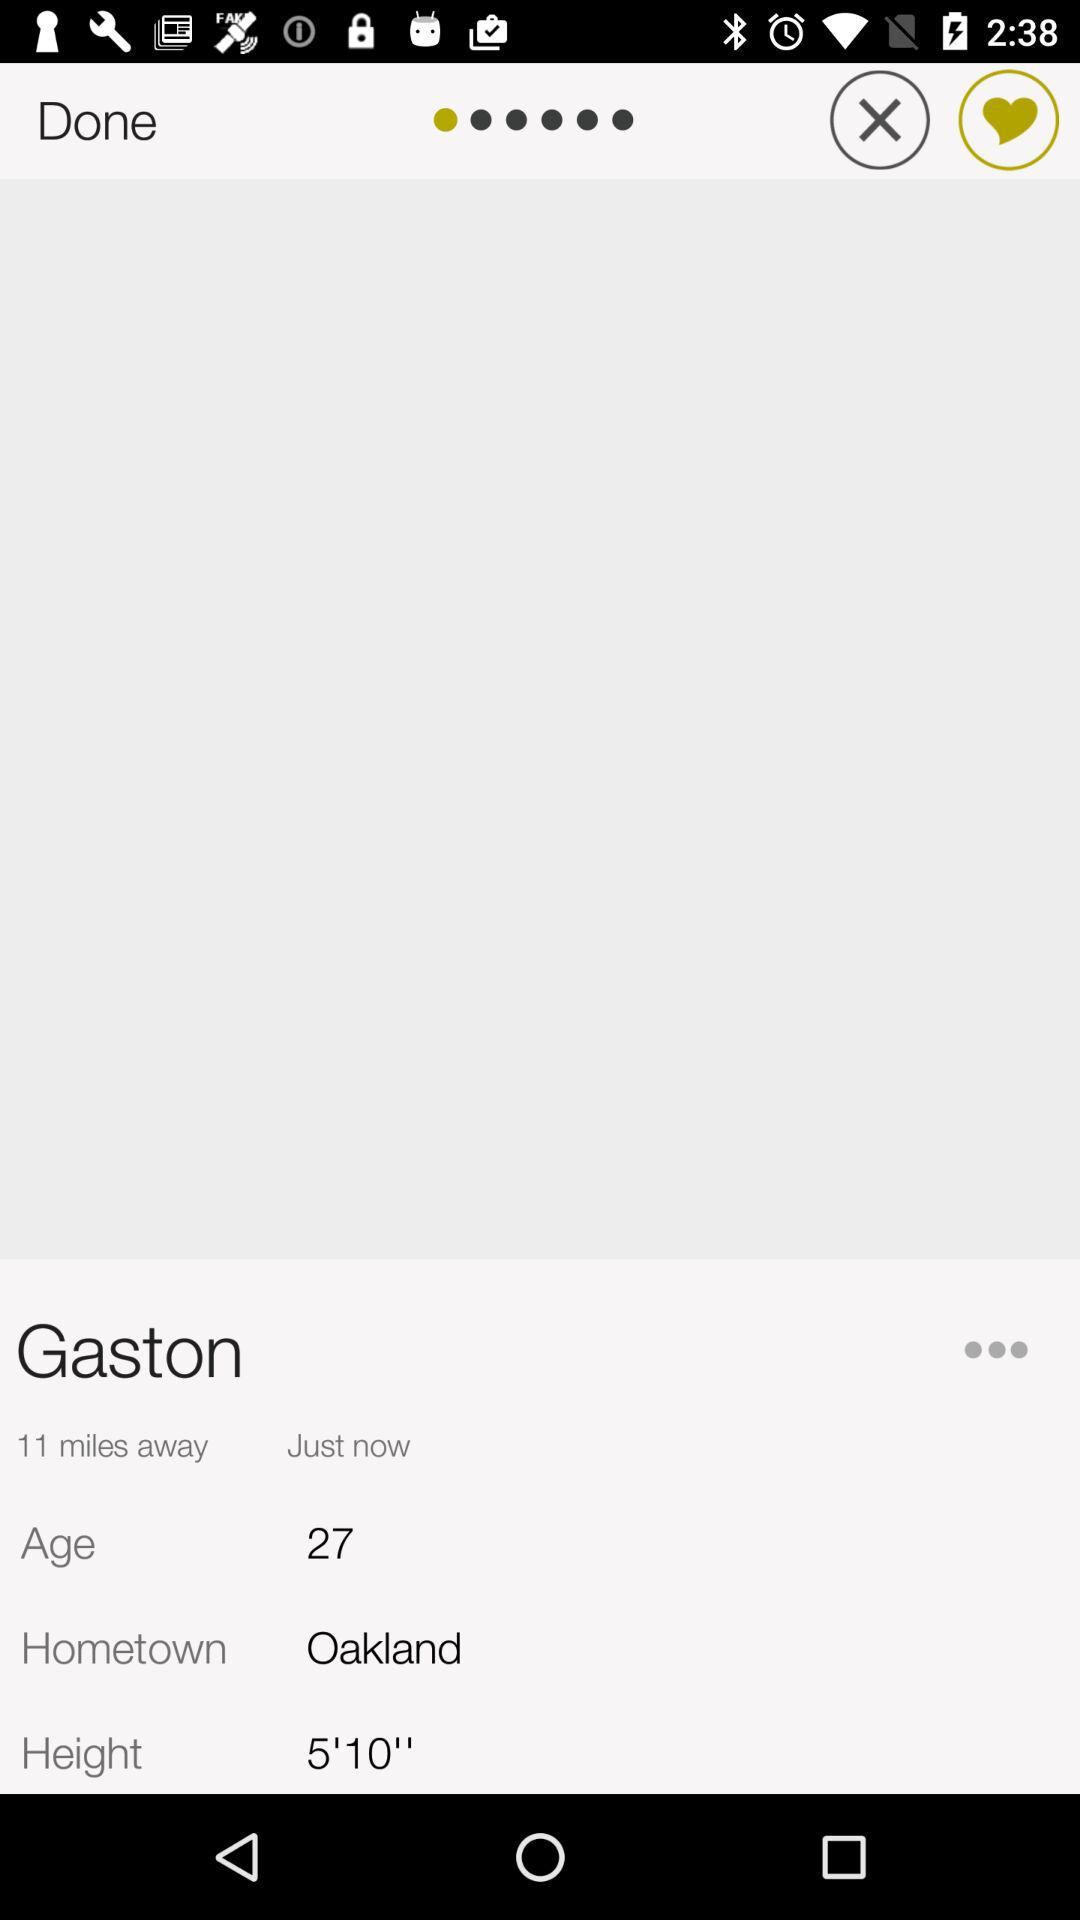How tall is Gaston?
Answer the question using a single word or phrase. 5'10" 